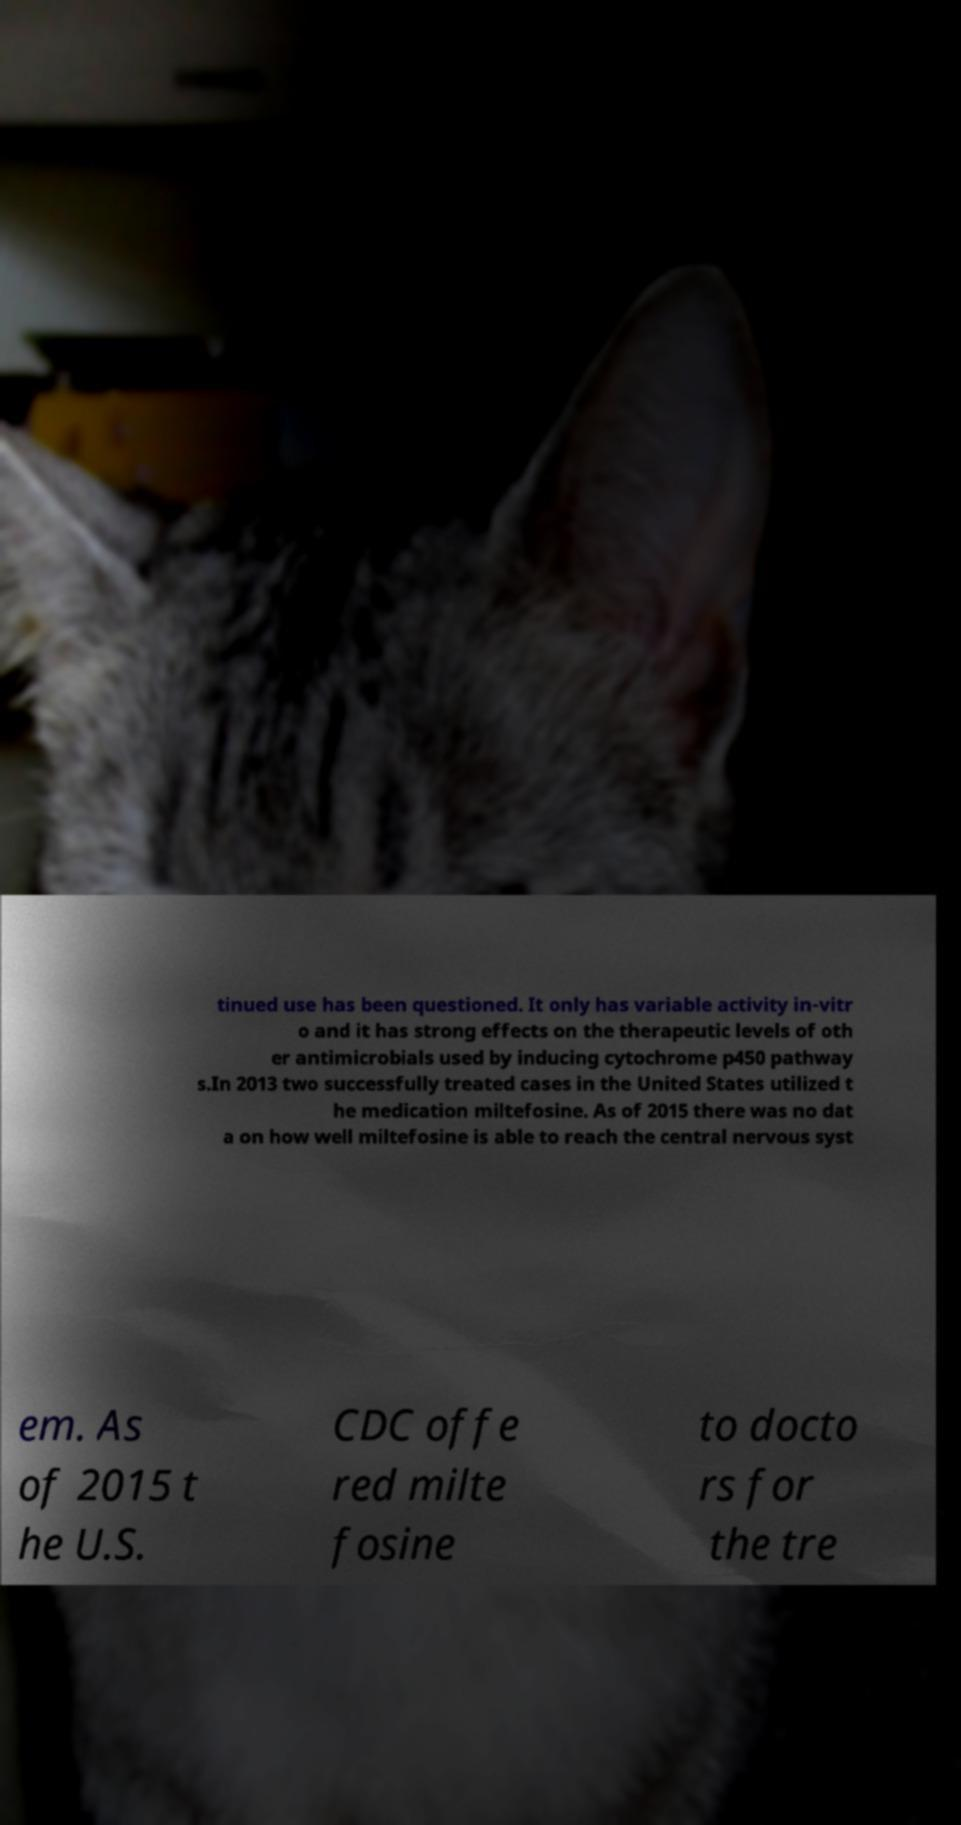Can you accurately transcribe the text from the provided image for me? tinued use has been questioned. It only has variable activity in-vitr o and it has strong effects on the therapeutic levels of oth er antimicrobials used by inducing cytochrome p450 pathway s.In 2013 two successfully treated cases in the United States utilized t he medication miltefosine. As of 2015 there was no dat a on how well miltefosine is able to reach the central nervous syst em. As of 2015 t he U.S. CDC offe red milte fosine to docto rs for the tre 